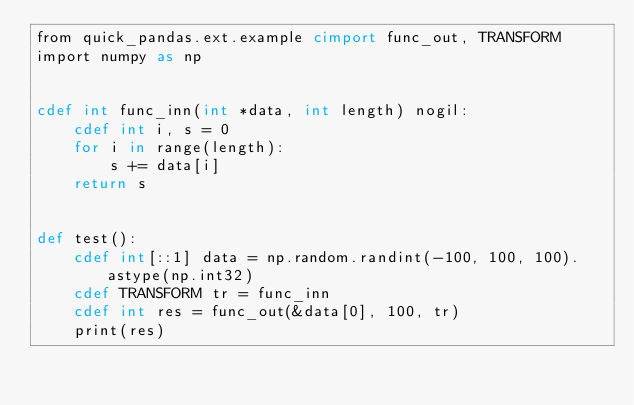<code> <loc_0><loc_0><loc_500><loc_500><_Cython_>from quick_pandas.ext.example cimport func_out, TRANSFORM
import numpy as np


cdef int func_inn(int *data, int length) nogil:
    cdef int i, s = 0
    for i in range(length):
        s += data[i]
    return s


def test():
    cdef int[::1] data = np.random.randint(-100, 100, 100).astype(np.int32)
    cdef TRANSFORM tr = func_inn
    cdef int res = func_out(&data[0], 100, tr)
    print(res)

</code> 